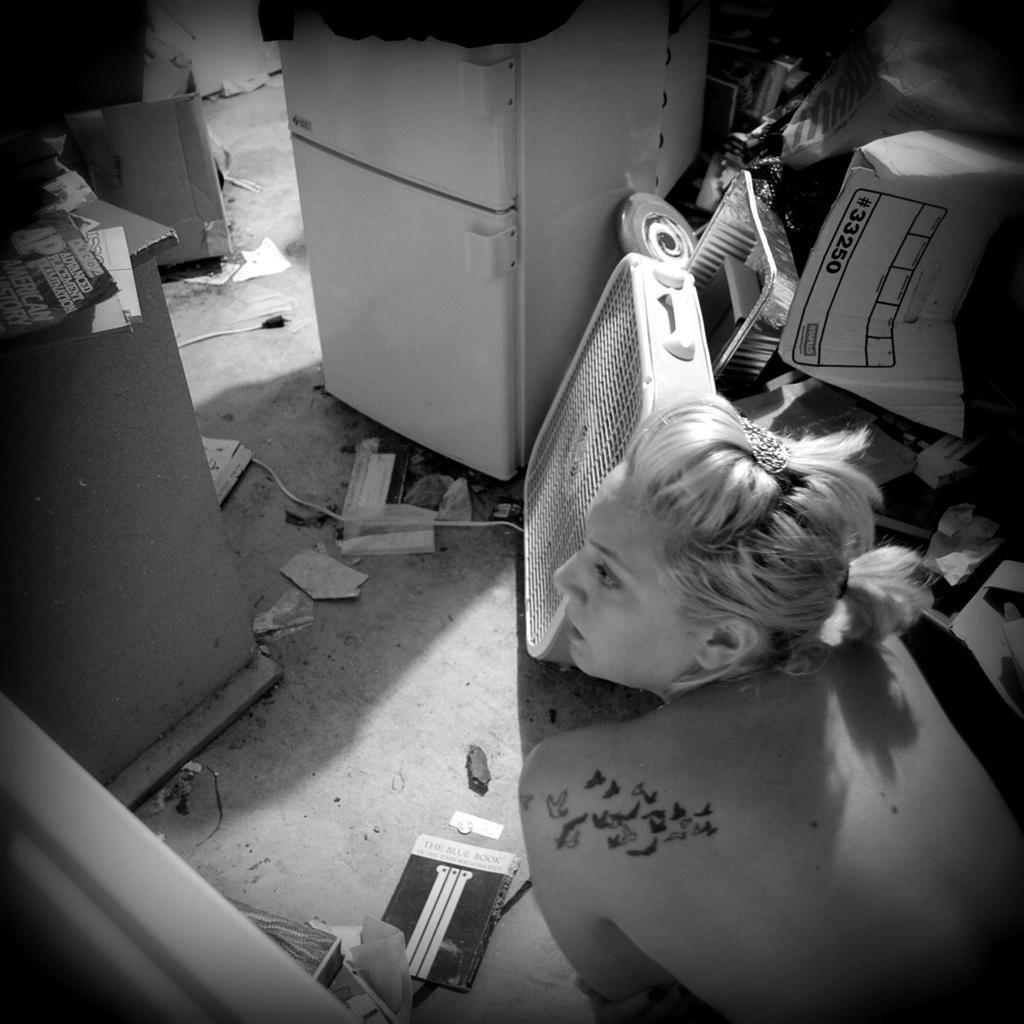Could you give a brief overview of what you see in this image? On the right side there is a lady. On the floor there are some papers. In the back there is a electronic machine, plate and some other items. 